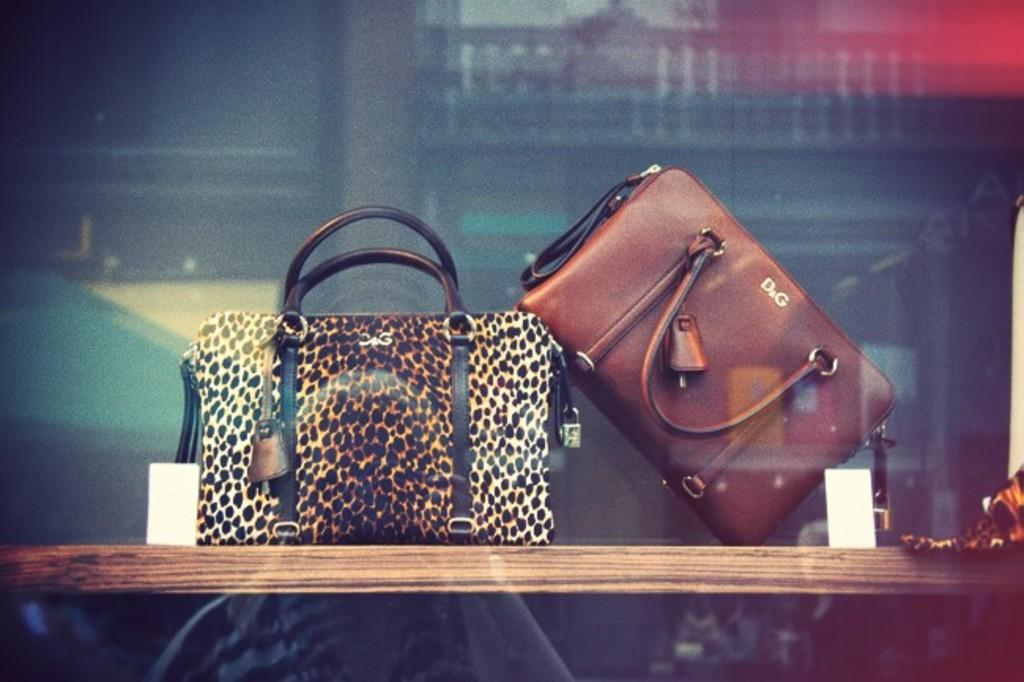How many bags are present in the image? There are two bags in the image. Where are the bags located? The bags are on a table. How can the bags be seen in the image? The bags are visible through a glass. What is attached to the bags? Tags are attached to the bags. What type of knowledge is being shared during the meeting in the image? There is no meeting present in the image, so it is not possible to determine what type of knowledge might be shared. 